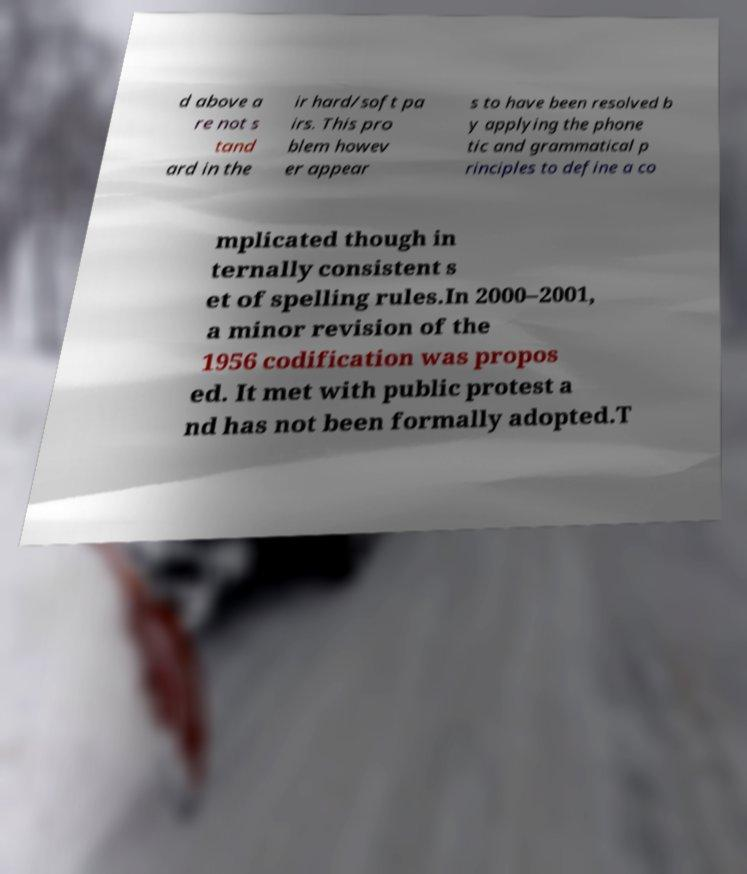Could you extract and type out the text from this image? d above a re not s tand ard in the ir hard/soft pa irs. This pro blem howev er appear s to have been resolved b y applying the phone tic and grammatical p rinciples to define a co mplicated though in ternally consistent s et of spelling rules.In 2000–2001, a minor revision of the 1956 codification was propos ed. It met with public protest a nd has not been formally adopted.T 